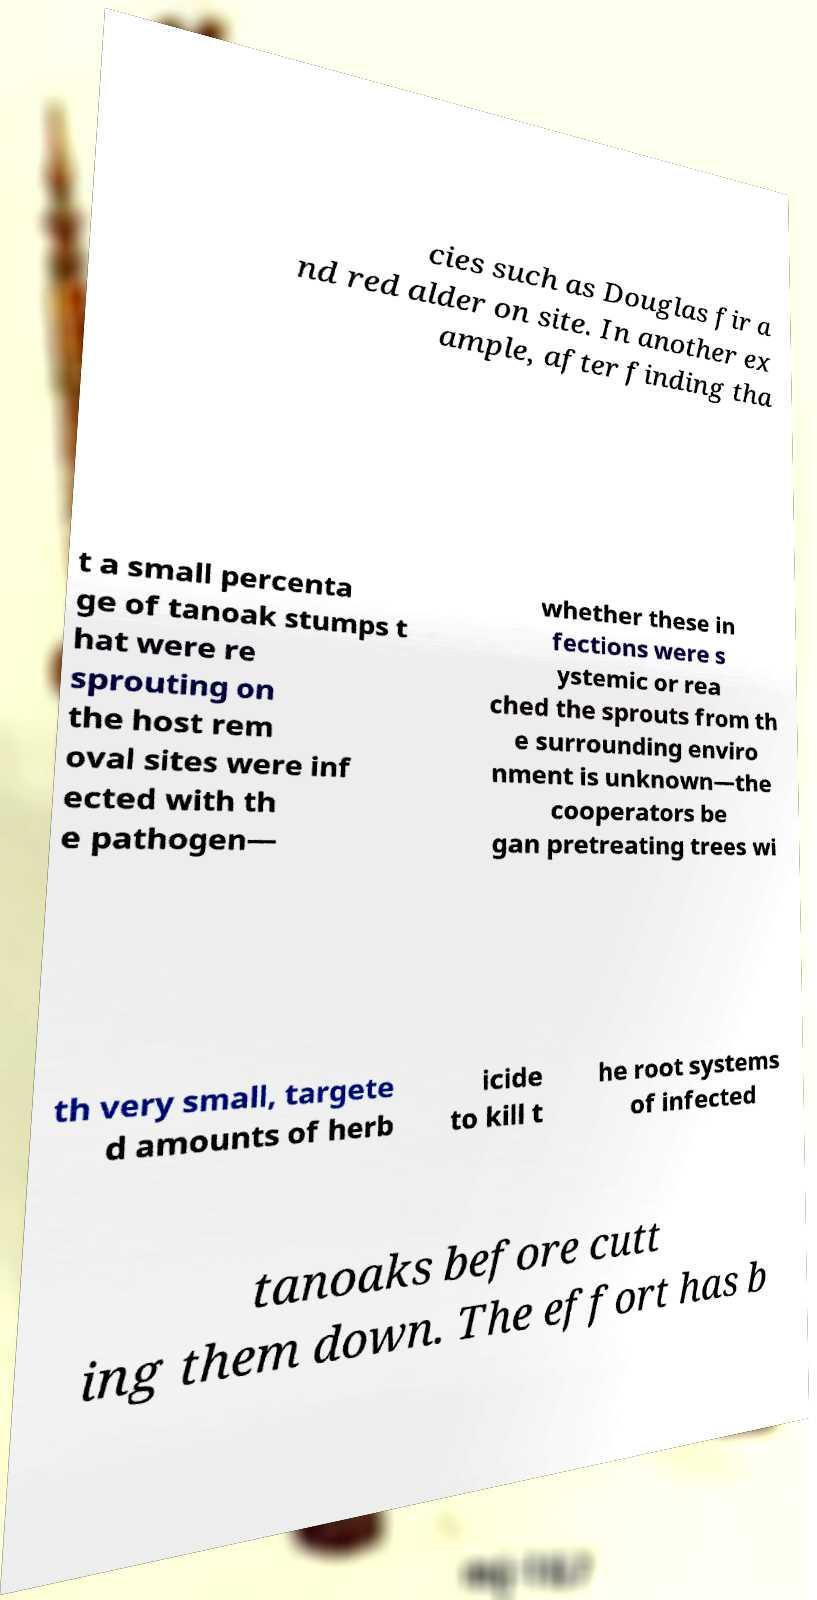What messages or text are displayed in this image? I need them in a readable, typed format. cies such as Douglas fir a nd red alder on site. In another ex ample, after finding tha t a small percenta ge of tanoak stumps t hat were re sprouting on the host rem oval sites were inf ected with th e pathogen— whether these in fections were s ystemic or rea ched the sprouts from th e surrounding enviro nment is unknown—the cooperators be gan pretreating trees wi th very small, targete d amounts of herb icide to kill t he root systems of infected tanoaks before cutt ing them down. The effort has b 